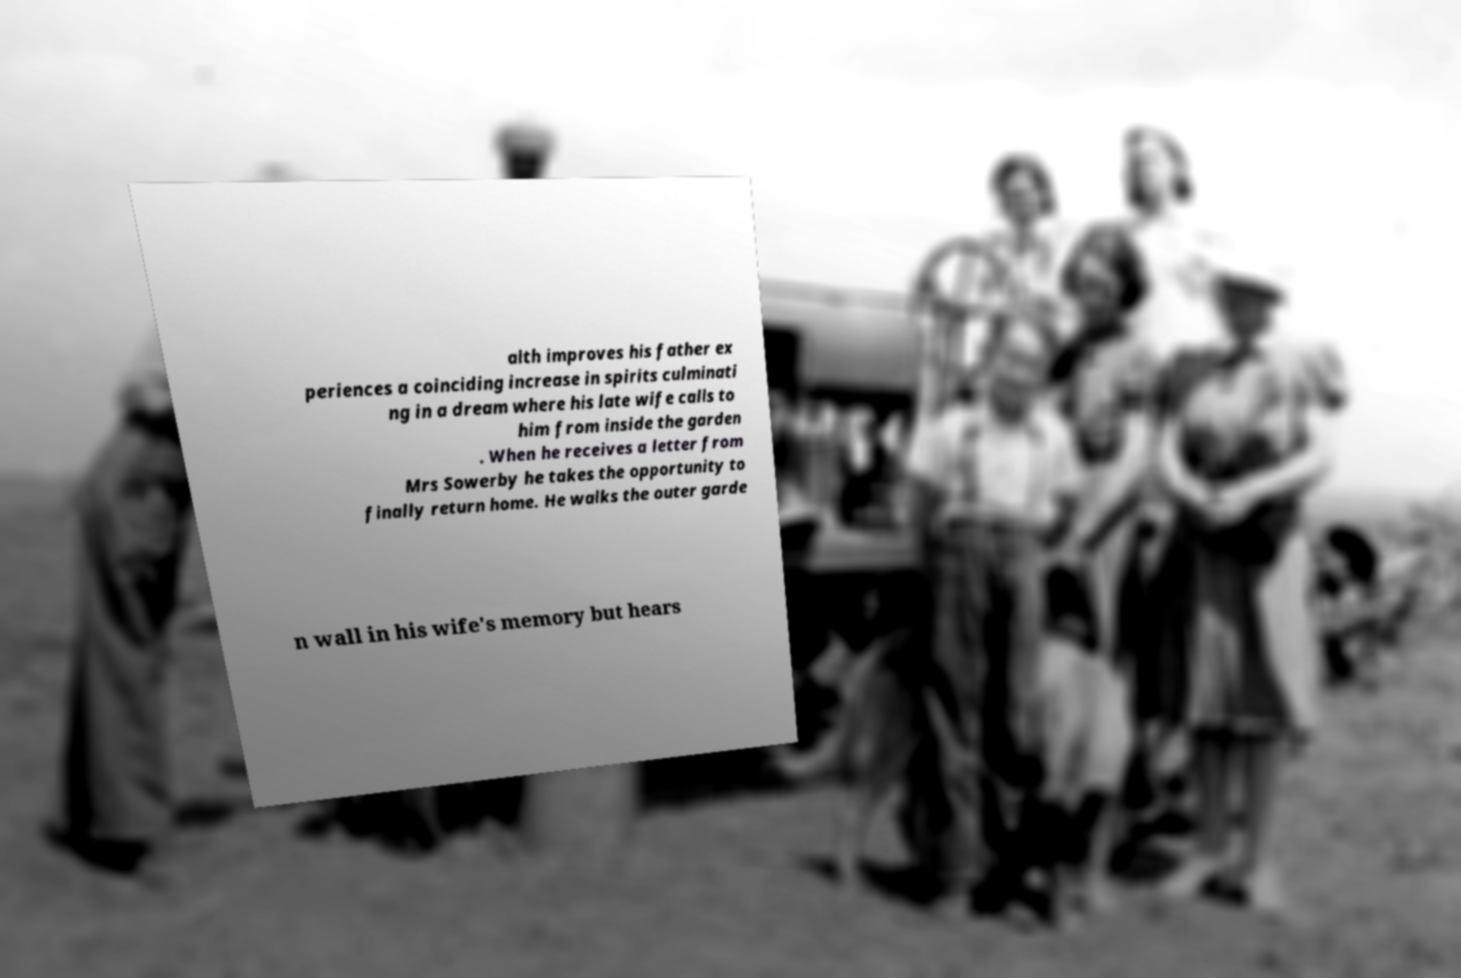Can you read and provide the text displayed in the image?This photo seems to have some interesting text. Can you extract and type it out for me? alth improves his father ex periences a coinciding increase in spirits culminati ng in a dream where his late wife calls to him from inside the garden . When he receives a letter from Mrs Sowerby he takes the opportunity to finally return home. He walks the outer garde n wall in his wife's memory but hears 